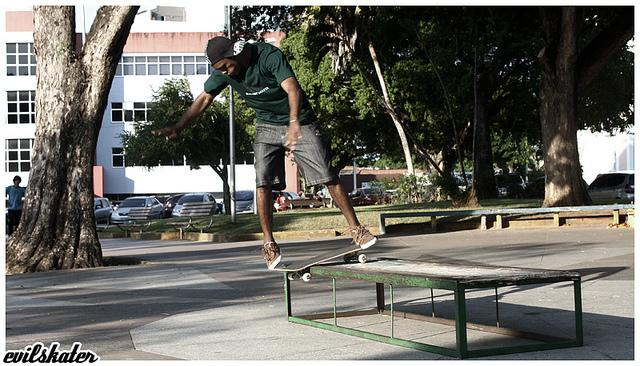What wheeled object is the man riding on to perform the stunt?

Choices:
A) motorcycle
B) skateboard
C) rollerblades
D) bike skateboard 